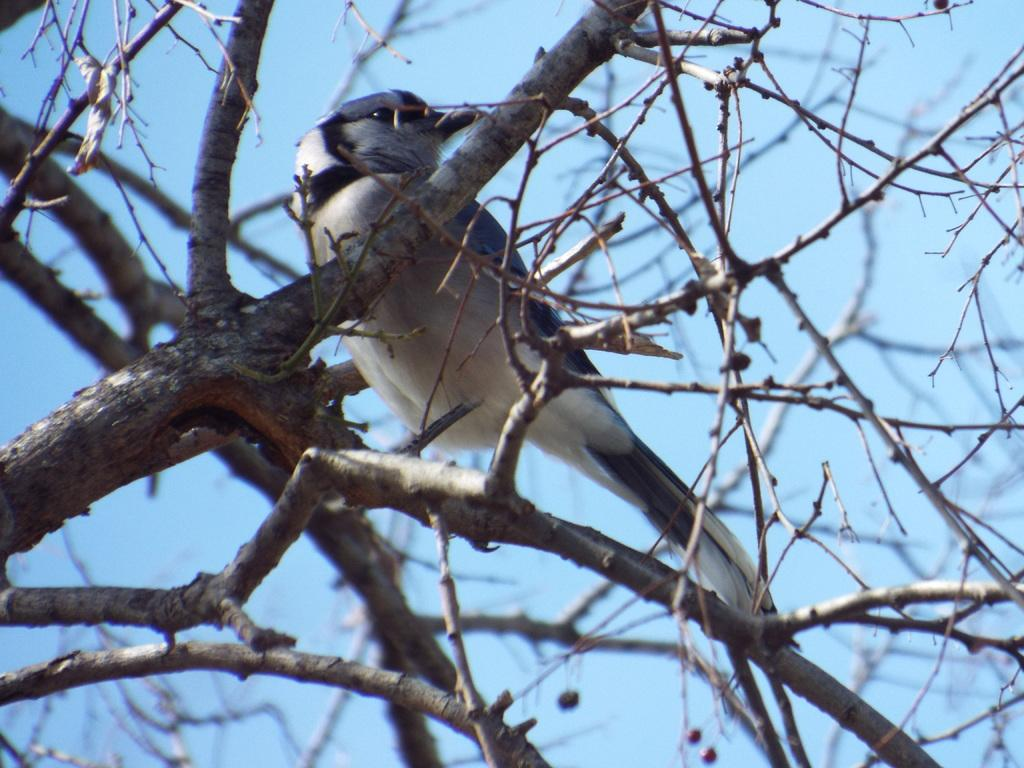What type of plant elements are visible in the image? There are branches and stems of a tree in the image. What animal can be seen on the tree in the image? There is a black and white colored bird on a branch in the image. What is visible in the background of the image? The sky is visible in the background of the image. What type of rhythm does the lawyer in the image use to communicate with the tree? There is no lawyer present in the image, and therefore no such communication can be observed. 